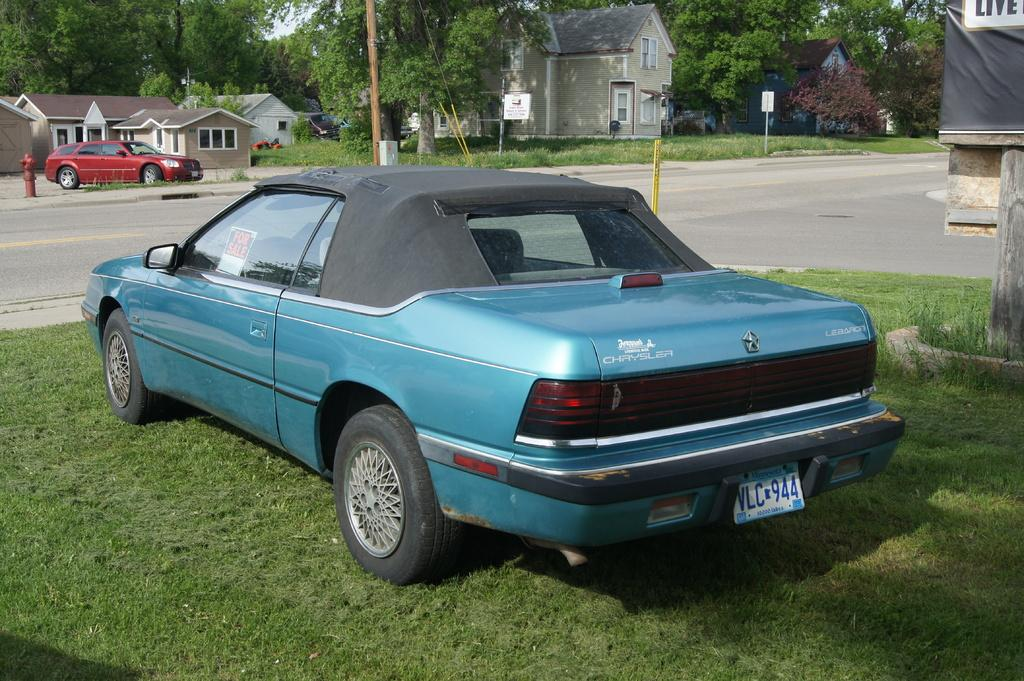What type of structures can be seen in the image? There are buildings in the image. What type of vegetation is present in the image? There are trees in the image. How many cars are visible in the image? There are two cars in the image. What type of pathway is present in the image? There is a road in the image. What type of ground cover can be seen in the image? There is grass on the ground in the image. What type of polish is being applied to the sister's nails in the image? There is no reference to polish or a sister in the image, so it is not possible to answer that question. 